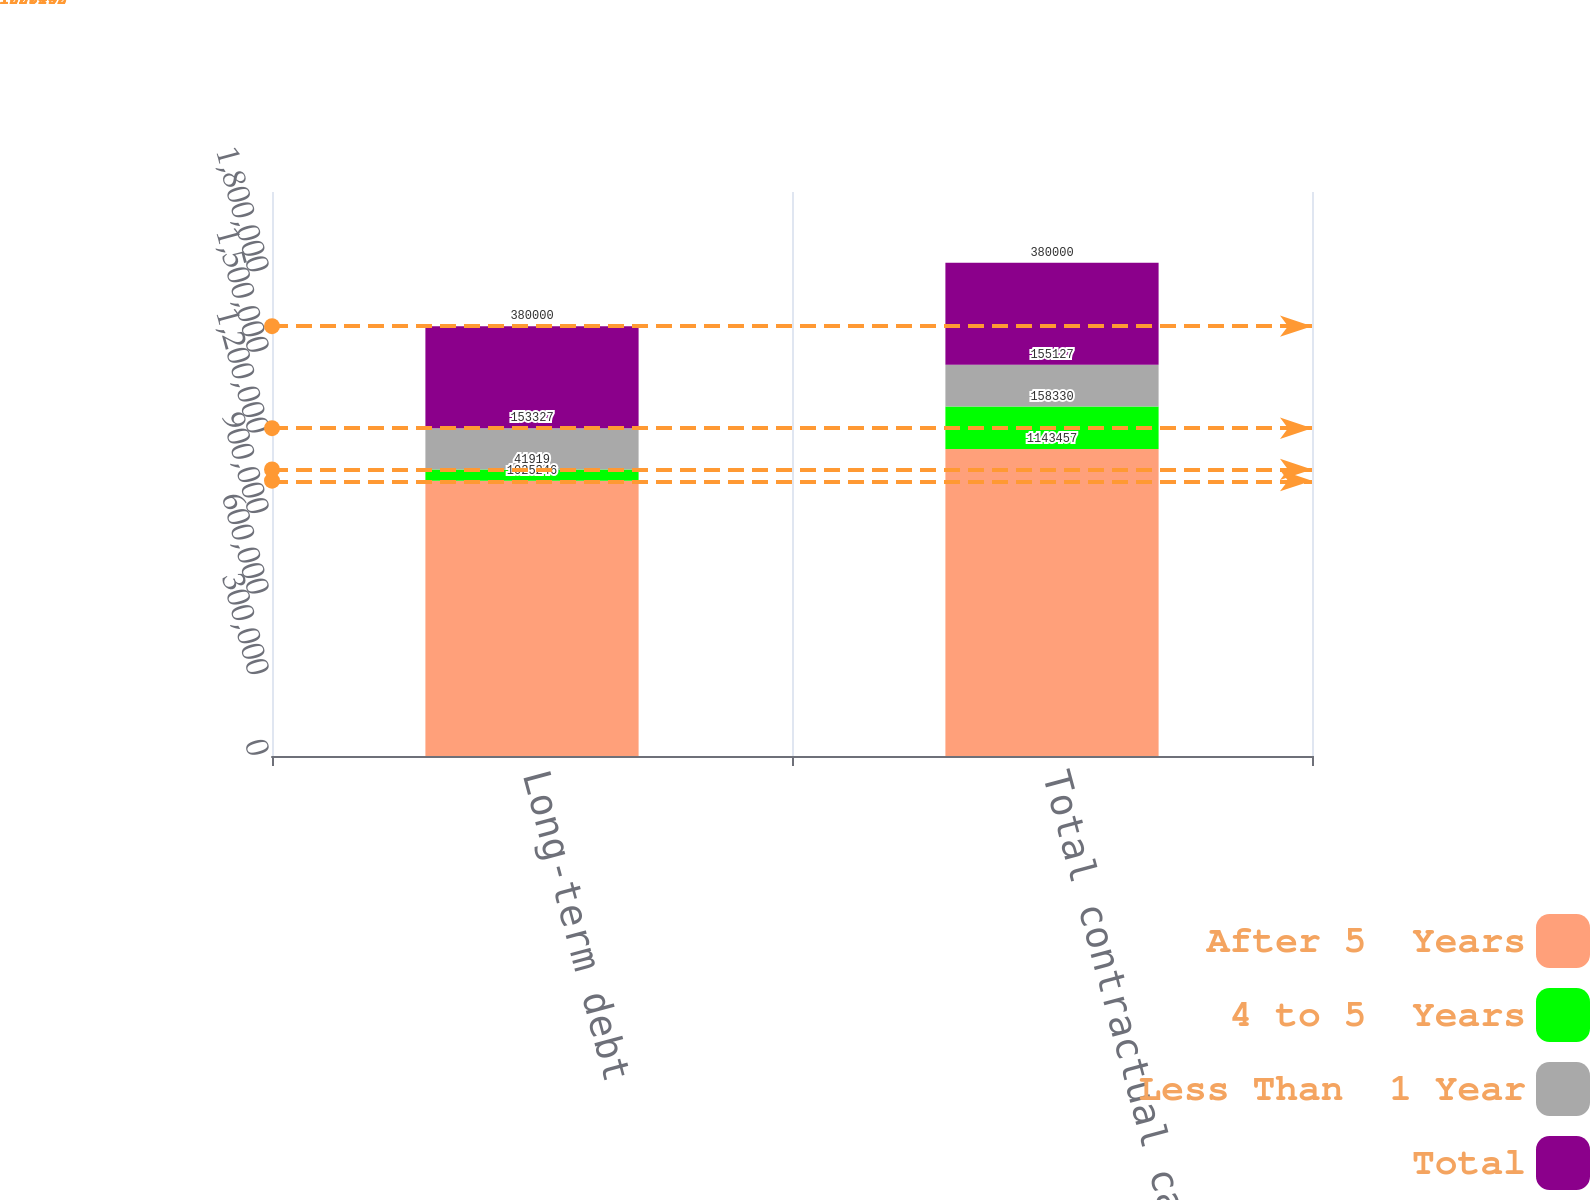Convert chart to OTSL. <chart><loc_0><loc_0><loc_500><loc_500><stacked_bar_chart><ecel><fcel>Long-term debt<fcel>Total contractual cash<nl><fcel>After 5  Years<fcel>1.02525e+06<fcel>1.14346e+06<nl><fcel>4 to 5  Years<fcel>41919<fcel>158330<nl><fcel>Less Than  1 Year<fcel>153327<fcel>155127<nl><fcel>Total<fcel>380000<fcel>380000<nl></chart> 